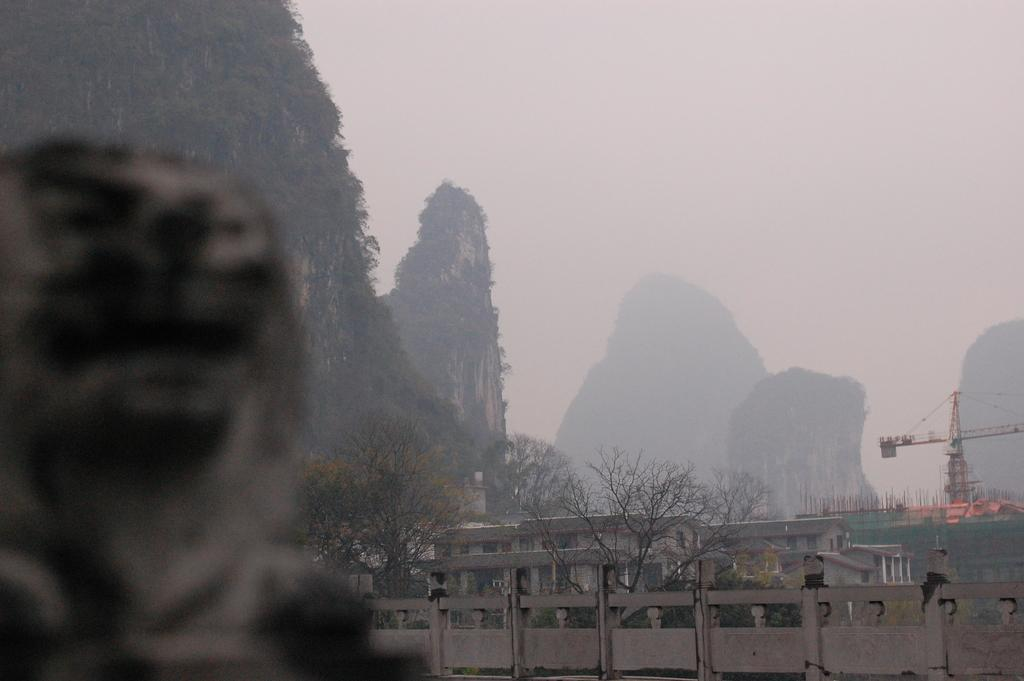What type of natural elements can be seen in the image? There are rocks and trees in the image. What man-made structures are present in the image? There is a crane, fencing, poles, and houses in the image. What part of the natural environment is visible in the image? The sky is visible in the image. What letters does the mom use to write a note with the knife in the image? There is no mom, letters, or knife present in the image. 